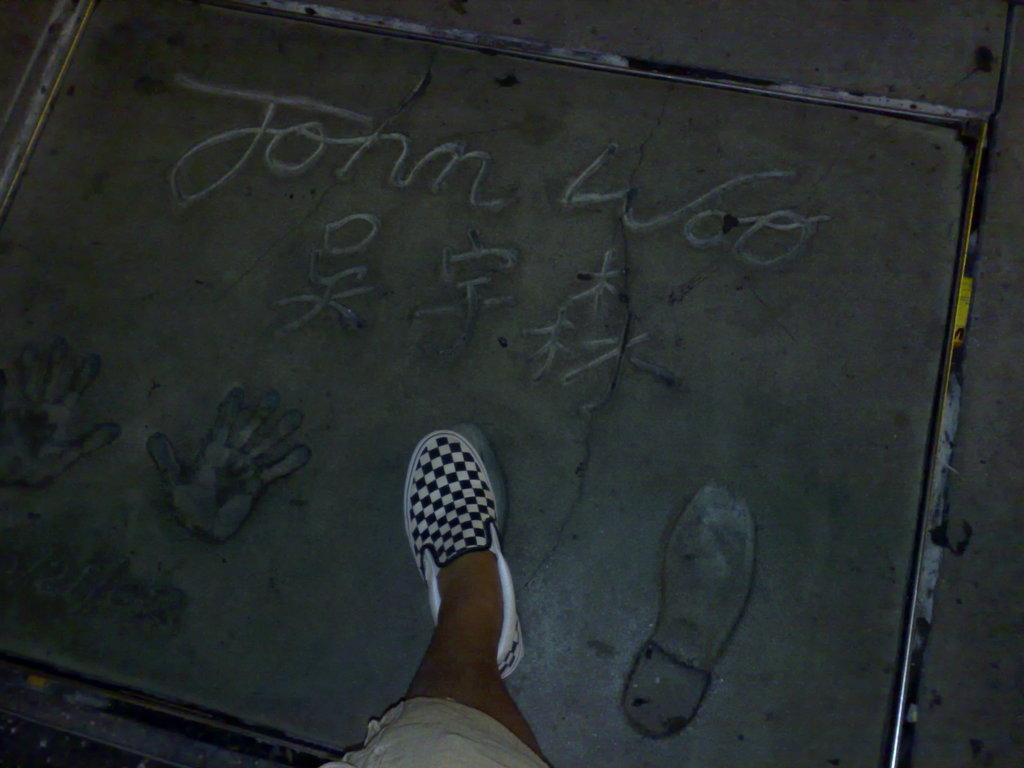In one or two sentences, can you explain what this image depicts? This image consists of a man walking. At the bottom, there is road. He is wearing white and black color shoes. 